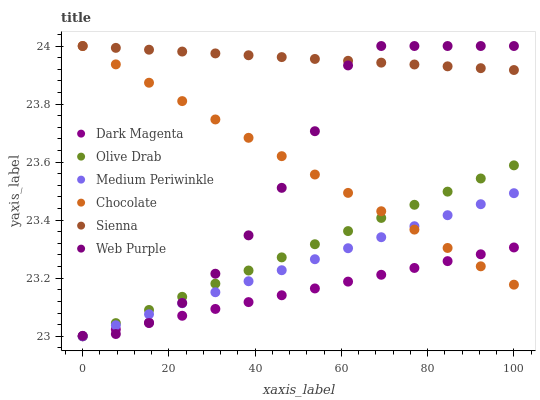Does Dark Magenta have the minimum area under the curve?
Answer yes or no. Yes. Does Sienna have the maximum area under the curve?
Answer yes or no. Yes. Does Medium Periwinkle have the minimum area under the curve?
Answer yes or no. No. Does Medium Periwinkle have the maximum area under the curve?
Answer yes or no. No. Is Dark Magenta the smoothest?
Answer yes or no. Yes. Is Web Purple the roughest?
Answer yes or no. Yes. Is Medium Periwinkle the smoothest?
Answer yes or no. No. Is Medium Periwinkle the roughest?
Answer yes or no. No. Does Dark Magenta have the lowest value?
Answer yes or no. Yes. Does Chocolate have the lowest value?
Answer yes or no. No. Does Web Purple have the highest value?
Answer yes or no. Yes. Does Medium Periwinkle have the highest value?
Answer yes or no. No. Is Olive Drab less than Sienna?
Answer yes or no. Yes. Is Sienna greater than Dark Magenta?
Answer yes or no. Yes. Does Web Purple intersect Olive Drab?
Answer yes or no. Yes. Is Web Purple less than Olive Drab?
Answer yes or no. No. Is Web Purple greater than Olive Drab?
Answer yes or no. No. Does Olive Drab intersect Sienna?
Answer yes or no. No. 